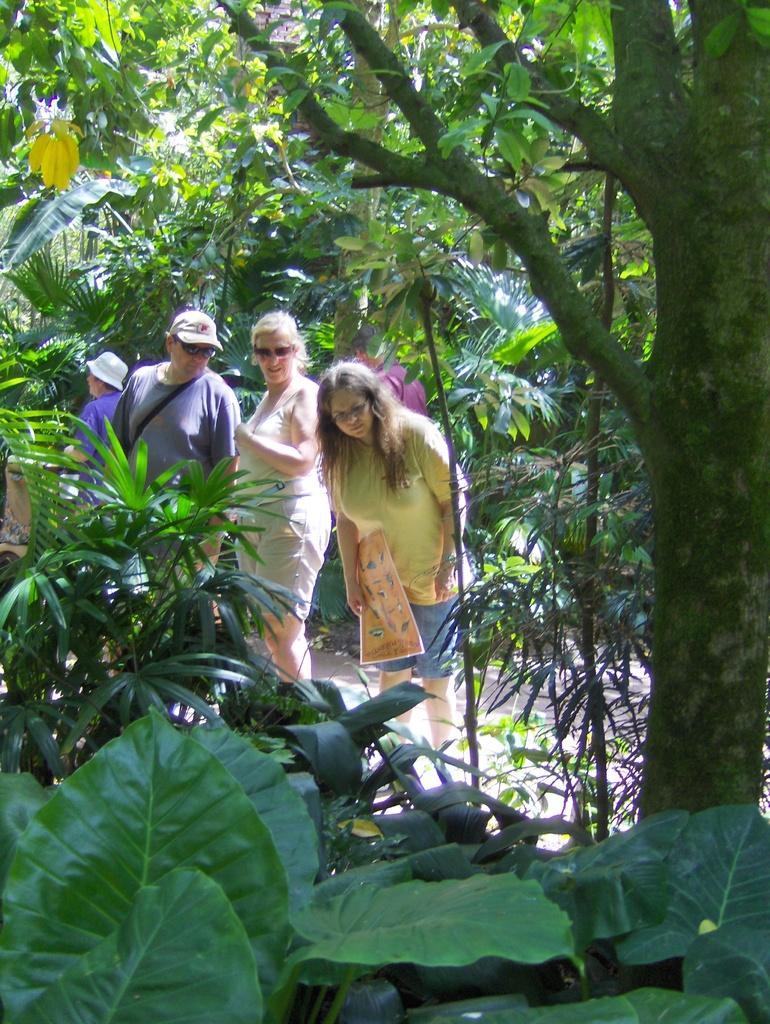Can you describe this image briefly? In this image we can see many plants and trees. There are four persons in the image. A lady is holding an object in the image. 